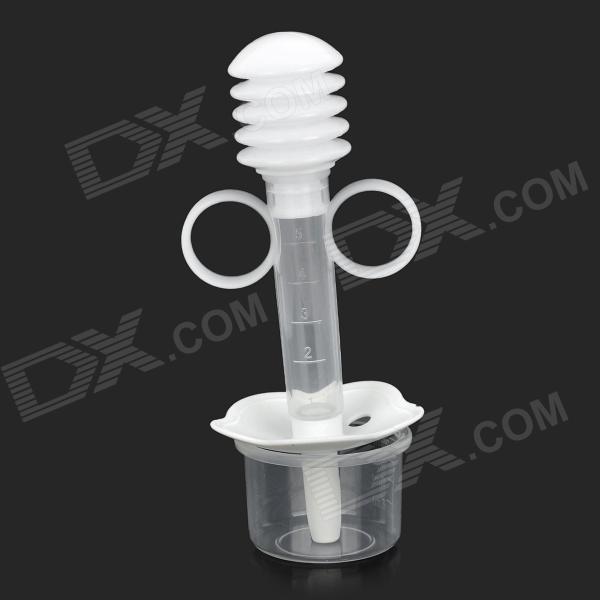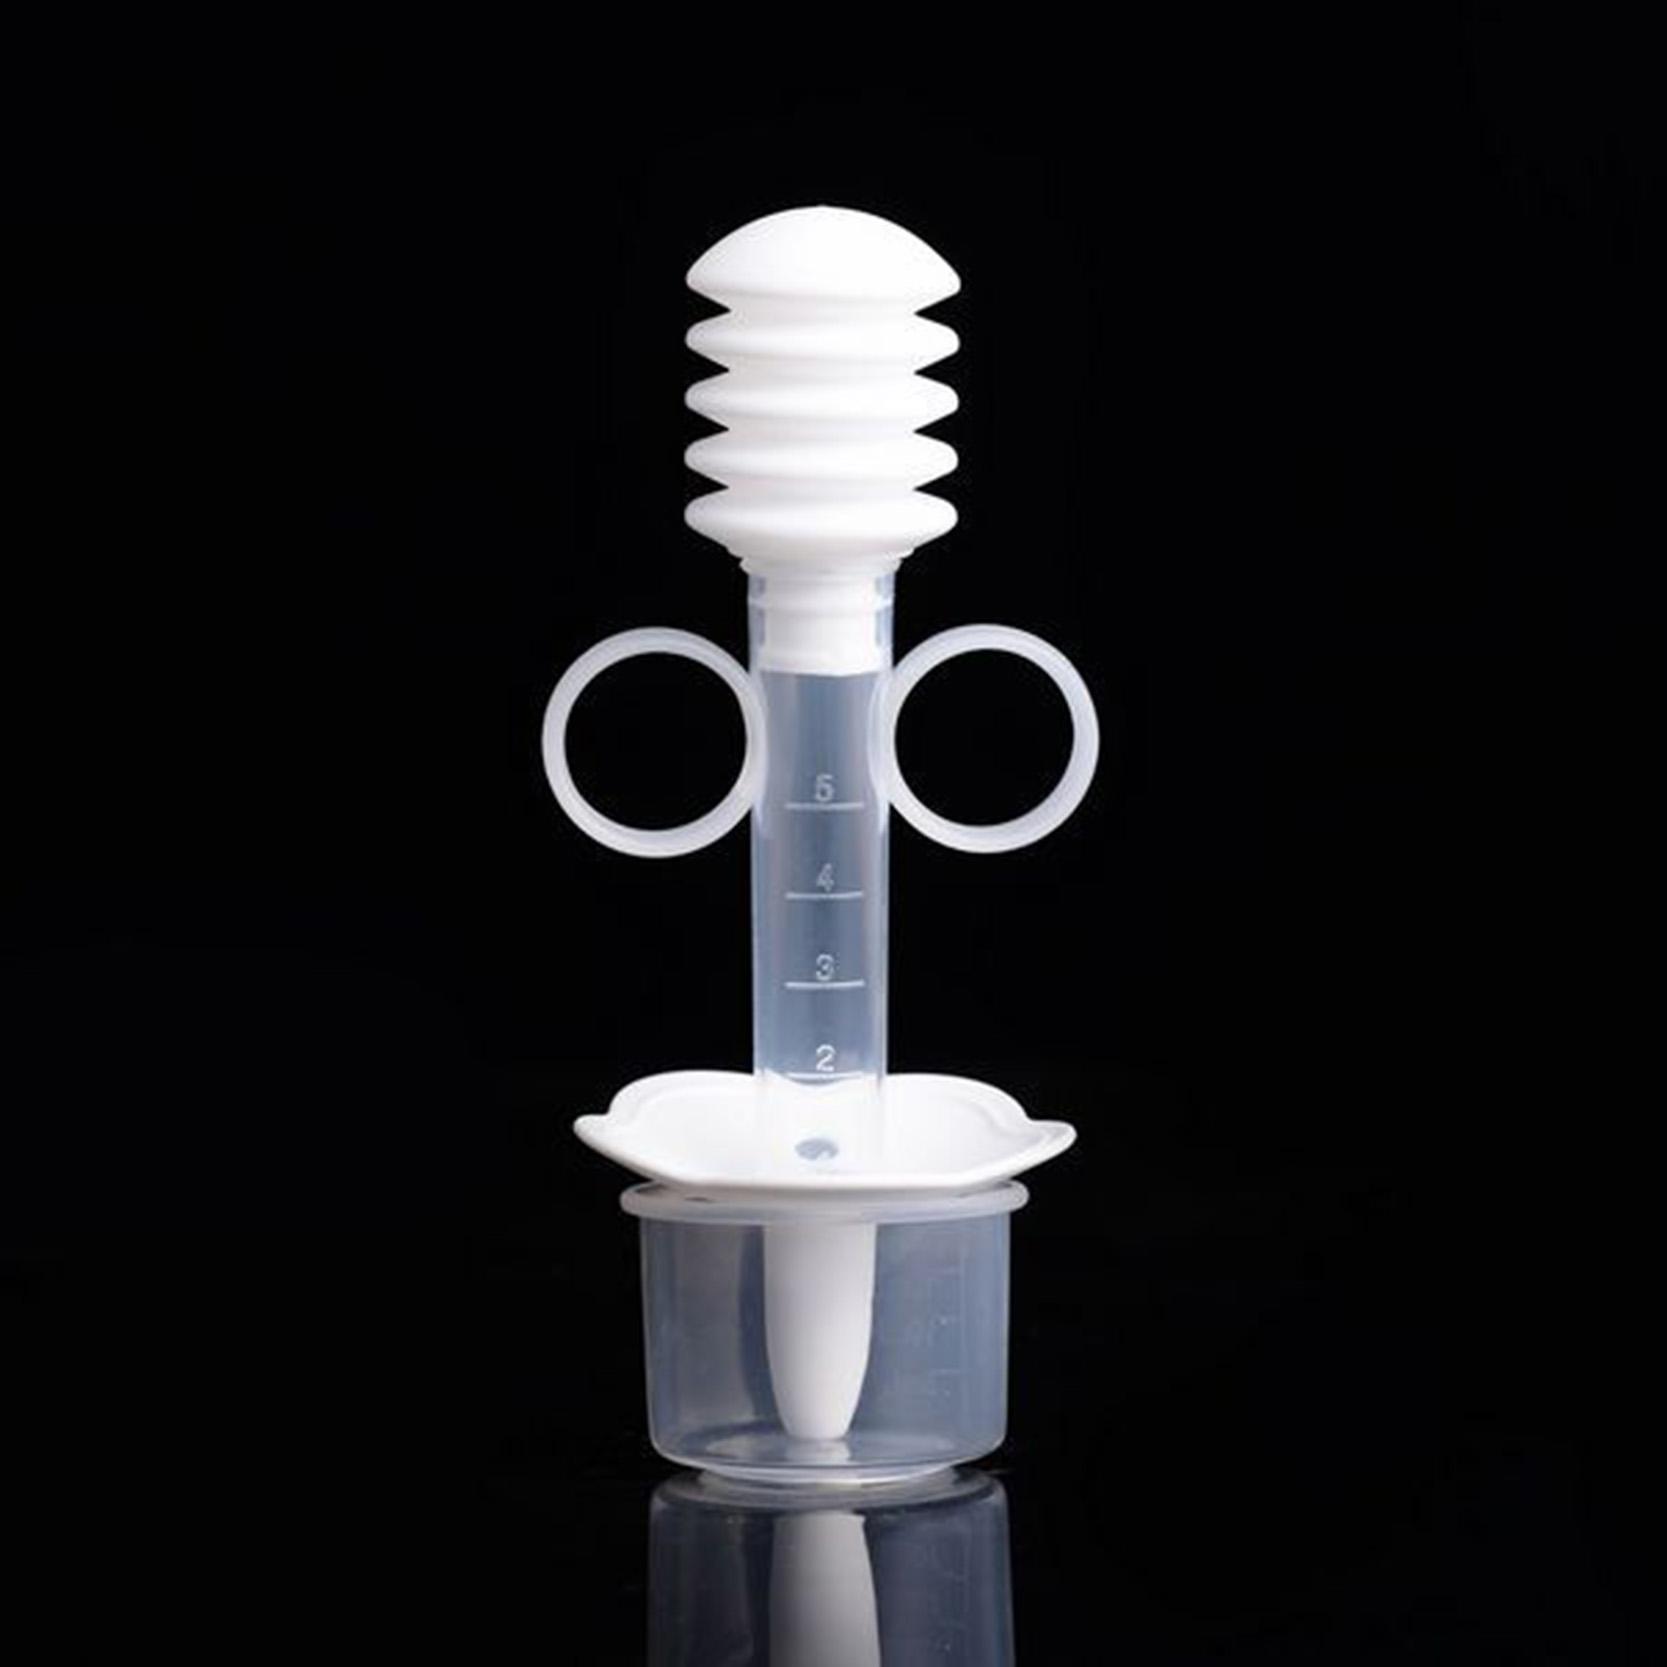The first image is the image on the left, the second image is the image on the right. Examine the images to the left and right. Is the description "There are exactly four syringes in one of the images." accurate? Answer yes or no. No. 